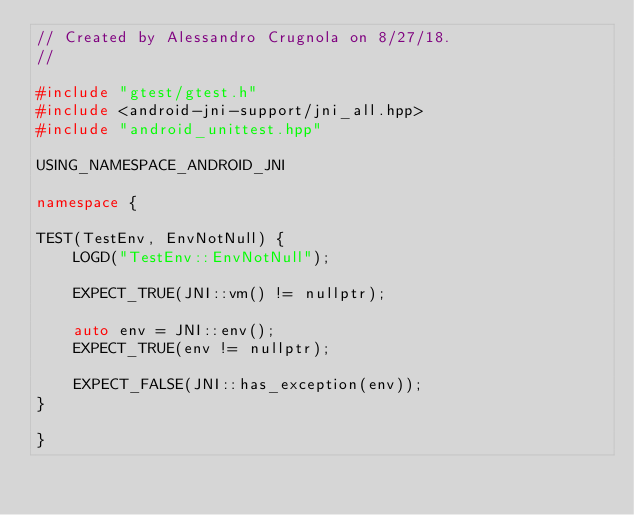Convert code to text. <code><loc_0><loc_0><loc_500><loc_500><_C++_>// Created by Alessandro Crugnola on 8/27/18.
//

#include "gtest/gtest.h"
#include <android-jni-support/jni_all.hpp>
#include "android_unittest.hpp"

USING_NAMESPACE_ANDROID_JNI

namespace {

TEST(TestEnv, EnvNotNull) {
    LOGD("TestEnv::EnvNotNull");

    EXPECT_TRUE(JNI::vm() != nullptr);

    auto env = JNI::env();
    EXPECT_TRUE(env != nullptr);

    EXPECT_FALSE(JNI::has_exception(env));
}

}
</code> 